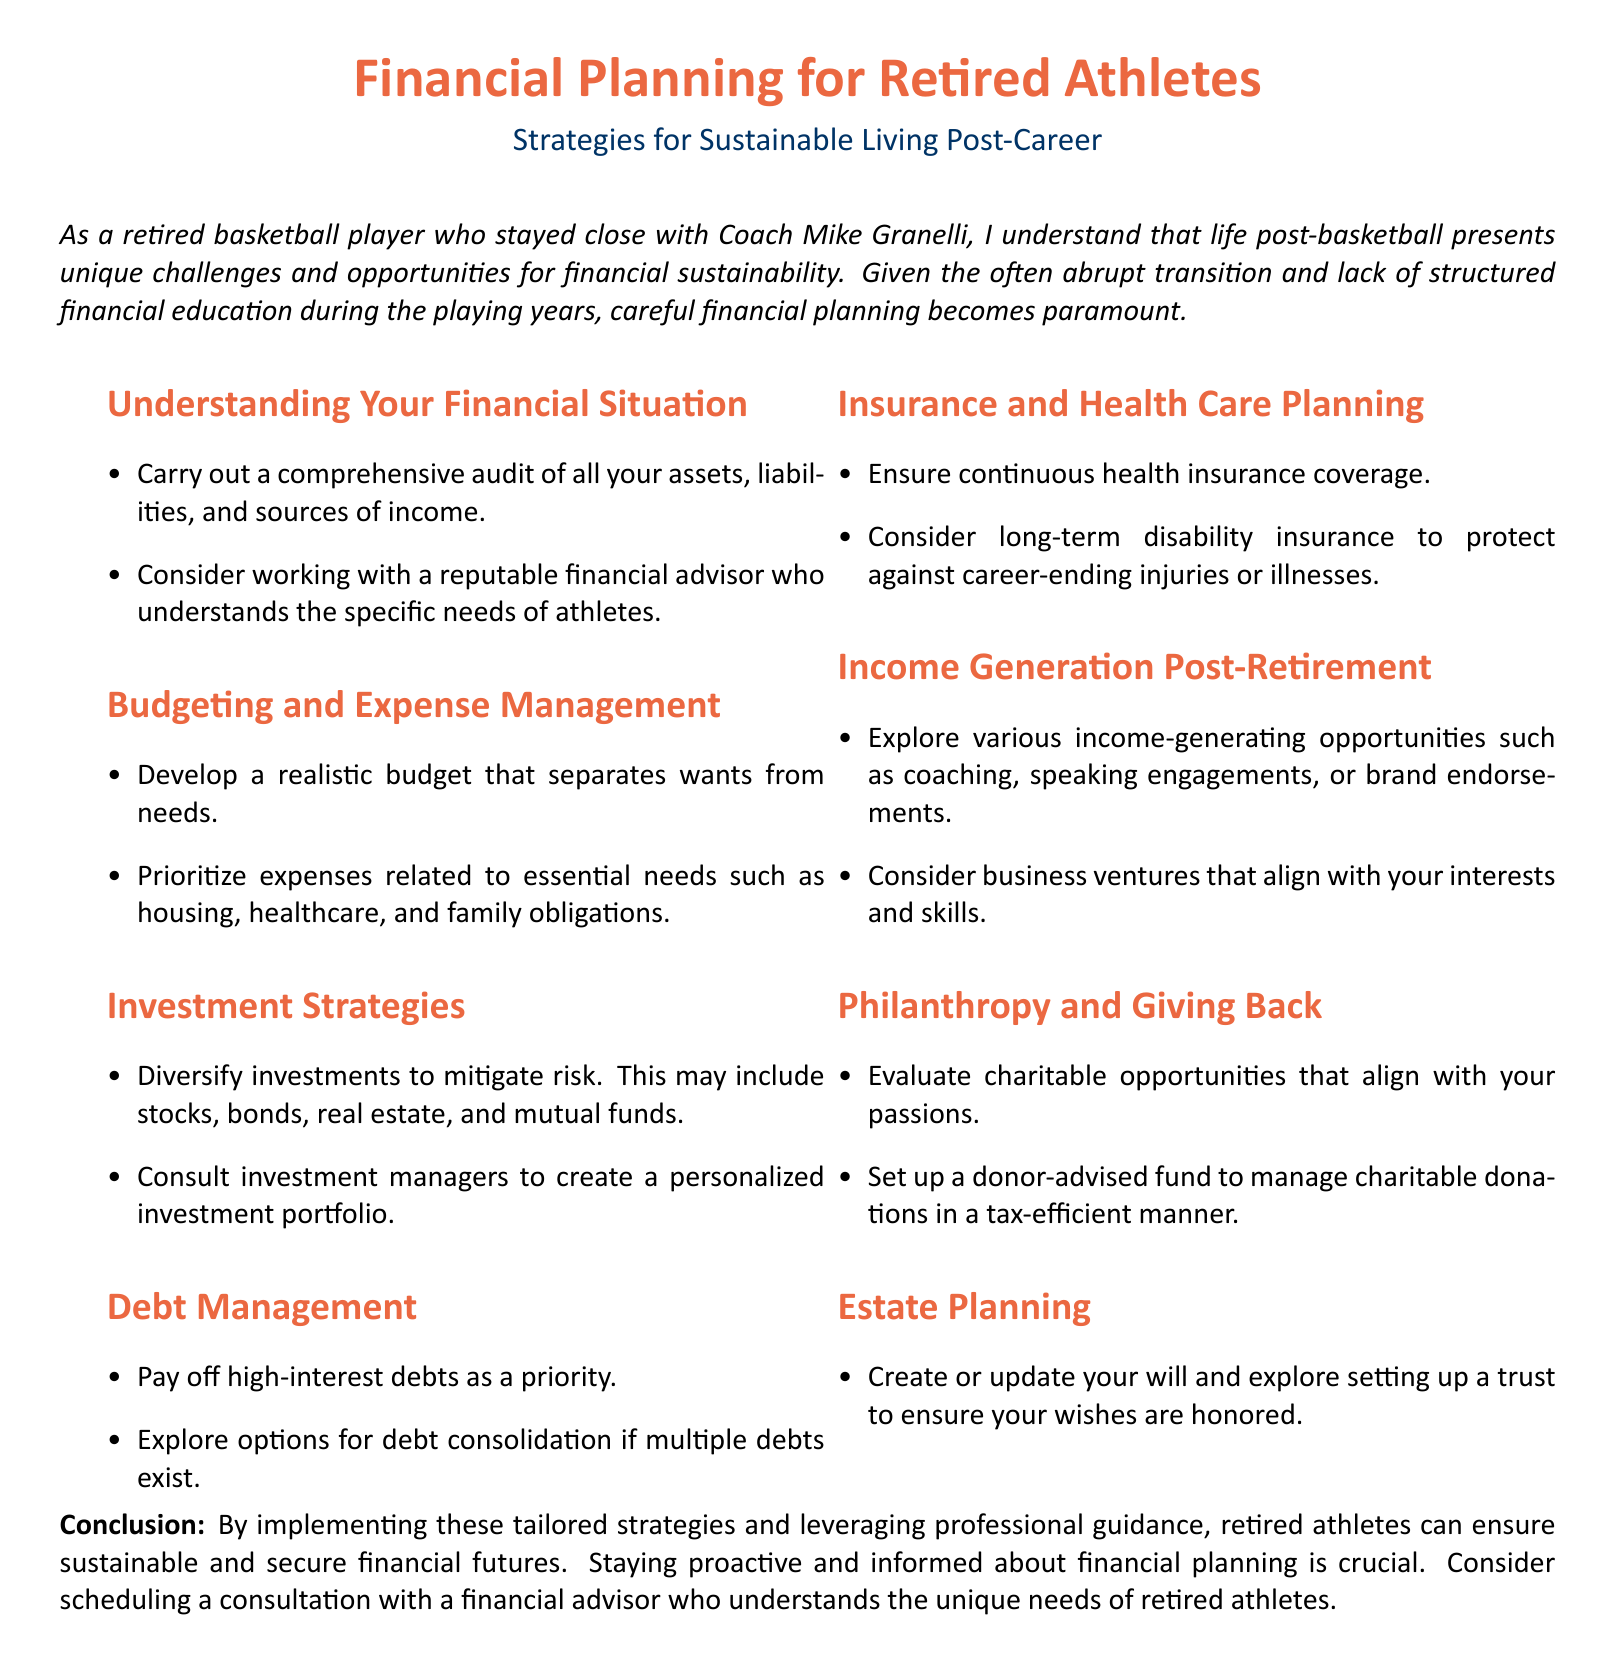What is the main focus of the document? The document discusses financial strategies for retired athletes to ensure sustainable living post-career.
Answer: Financial strategies What is a recommended first step in understanding your financial situation? The document suggests carrying out a comprehensive audit of assets, liabilities, and income sources.
Answer: Comprehensive audit What type of insurance should retired athletes ensure they have? The document emphasizes the importance of continuous health insurance coverage.
Answer: Health insurance What is one potential income-generating opportunity mentioned? The document highlights coaching as a potential income source for retired athletes.
Answer: Coaching What does the whitepaper recommend for high-interest debts? It advises prioritizing the payment of high-interest debts.
Answer: Pay off high-interest debts Which financial professional is suggested for assistance? The document recommends working with a reputable financial advisor.
Answer: Financial advisor What should be evaluated for charitable activities? The document encourages evaluating charitable opportunities that align with personal passions.
Answer: Charitable opportunities What estate planning document should be created or updated? The document advises creating or updating a will.
Answer: Will What is a good investment strategy mentioned in the document? It advocates for diversifying investments to mitigate risk.
Answer: Diversify investments 